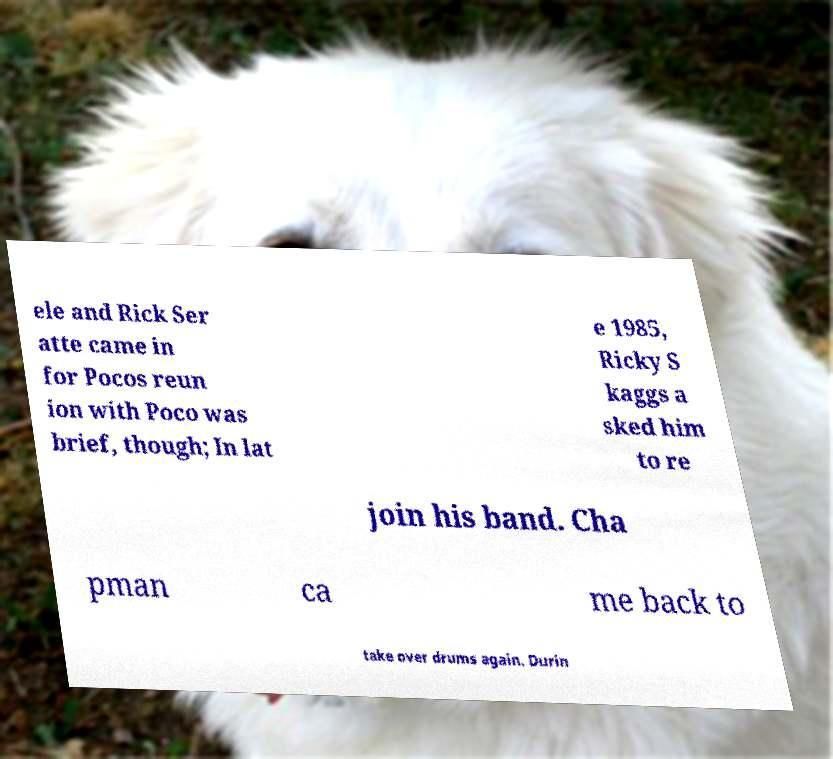I need the written content from this picture converted into text. Can you do that? ele and Rick Ser atte came in for Pocos reun ion with Poco was brief, though; In lat e 1985, Ricky S kaggs a sked him to re join his band. Cha pman ca me back to take over drums again. Durin 